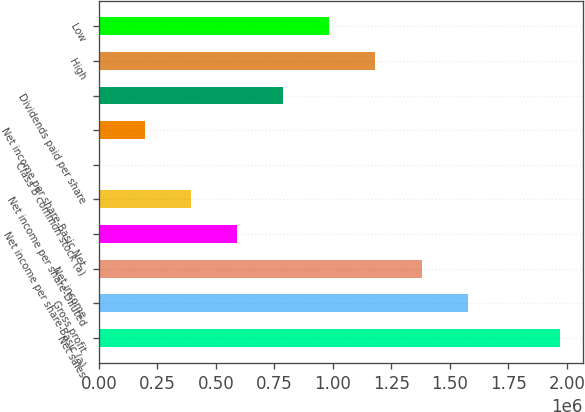<chart> <loc_0><loc_0><loc_500><loc_500><bar_chart><fcel>Net sales<fcel>Gross profit<fcel>Net income<fcel>Net income per share-Basic (a)<fcel>Net income per share-Diluted<fcel>Class B common stock (a)<fcel>Net income per share-Basic Net<fcel>Dividends paid per share<fcel>High<fcel>Low<nl><fcel>1.97024e+06<fcel>1.5762e+06<fcel>1.37917e+06<fcel>591074<fcel>394049<fcel>0.51<fcel>197025<fcel>788098<fcel>1.18215e+06<fcel>985122<nl></chart> 